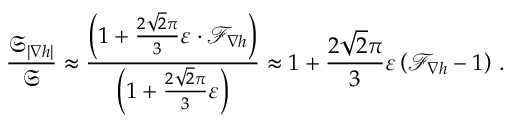Convert formula to latex. <formula><loc_0><loc_0><loc_500><loc_500>\frac { \mathfrak { S } _ { | \nabla h | } } { \mathfrak { S } } \approx \frac { \left ( 1 + \frac { 2 \sqrt { 2 } \pi } { 3 } \varepsilon \cdot \mathcal { F } _ { \nabla h } \right ) } { \left ( 1 + \frac { 2 \sqrt { 2 } \pi } { 3 } \varepsilon \right ) } \approx 1 + \frac { 2 \sqrt { 2 } \pi } { 3 } \varepsilon \left ( \mathcal { F } _ { \nabla h } - 1 \right ) \, .</formula> 